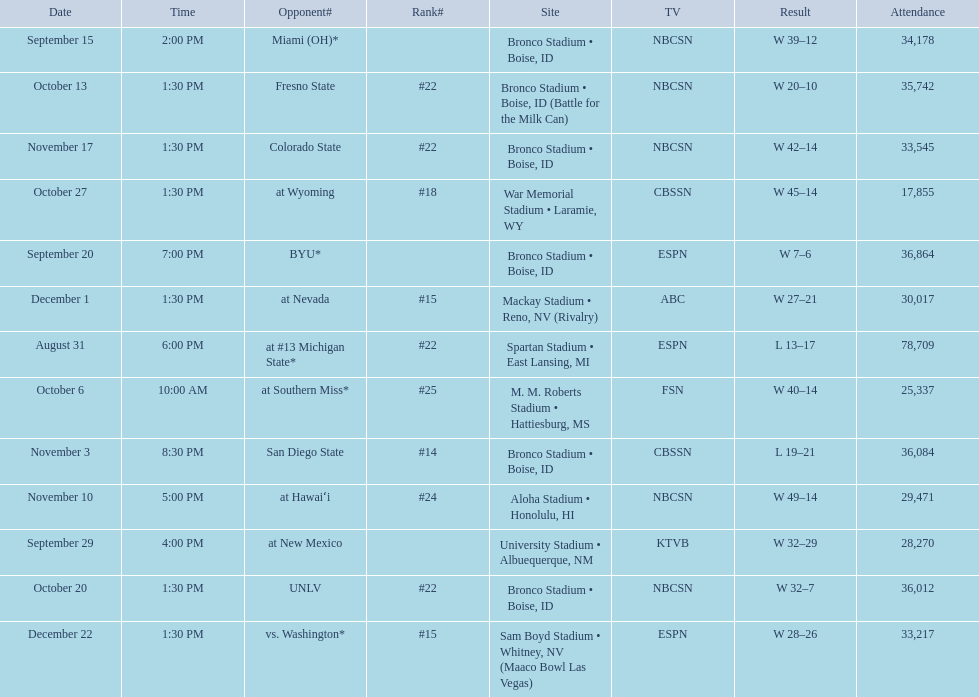Add up the total number of points scored in the last wins for boise state. 146. 